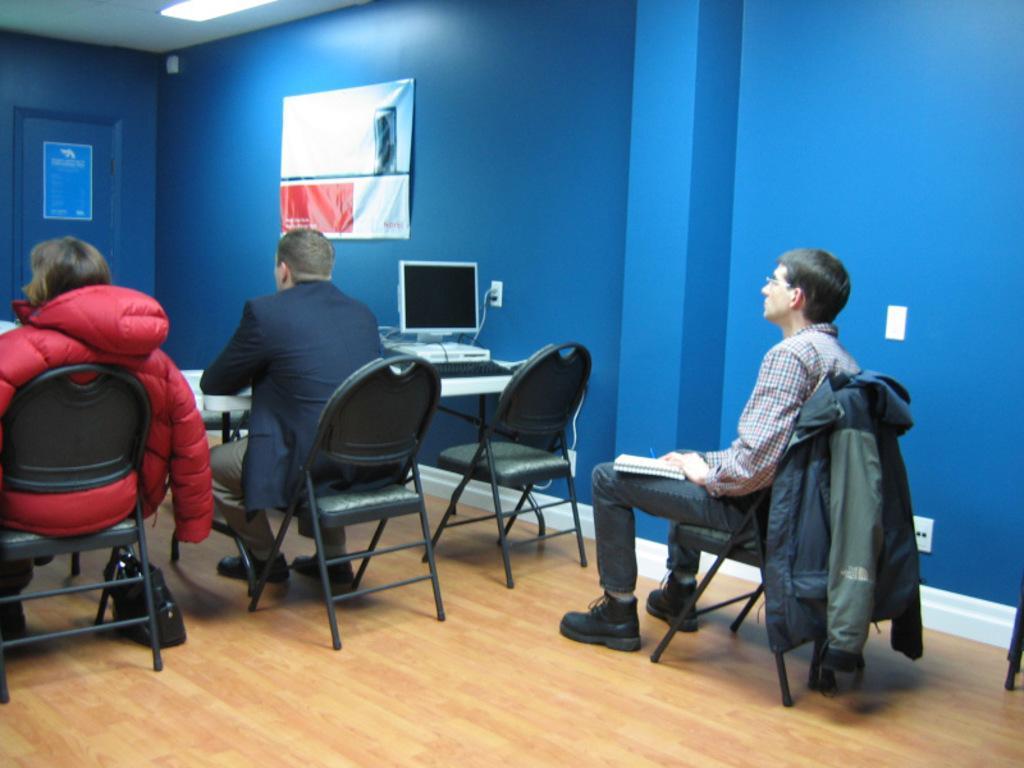Can you describe this image briefly? In this Picture we can describe a girl wearing red puff jacket setting on the chair and looking in front and other person sitting beside him also looking front, Behind there is other person who is sitting on the chair wearing red and black color check shirt holding a dairy in the hand and seeing front. This is the inside view of a room in which blue color wall and poster can be seen. 